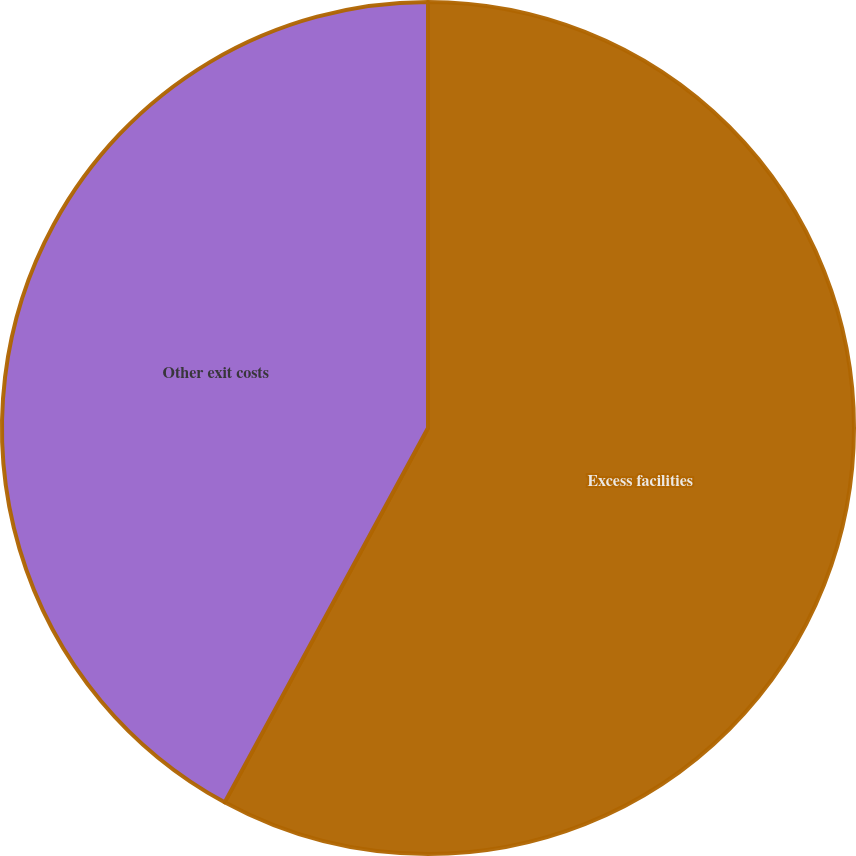<chart> <loc_0><loc_0><loc_500><loc_500><pie_chart><fcel>Excess facilities<fcel>Other exit costs<nl><fcel>57.92%<fcel>42.08%<nl></chart> 